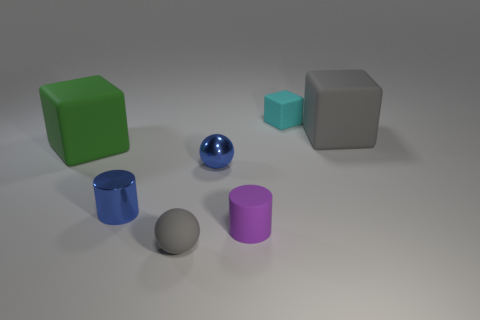Subtract all big cubes. How many cubes are left? 1 Add 2 blue balls. How many objects exist? 9 Subtract all balls. How many objects are left? 5 Add 5 metal cylinders. How many metal cylinders exist? 6 Subtract 0 gray cylinders. How many objects are left? 7 Subtract all small cyan objects. Subtract all big green cubes. How many objects are left? 5 Add 2 gray blocks. How many gray blocks are left? 3 